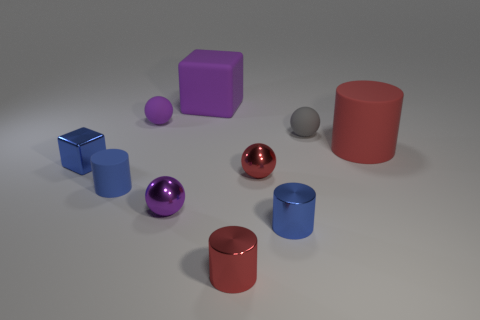What is the material of the cube that is the same color as the small rubber cylinder?
Your answer should be very brief. Metal. How many objects are the same color as the metallic cube?
Your answer should be very brief. 2. What number of objects are either blue cylinders that are to the right of the big purple rubber block or rubber objects right of the big purple thing?
Provide a succinct answer. 3. There is a cube that is in front of the large red object; what number of red rubber objects are in front of it?
Offer a terse response. 0. There is a large thing that is the same material as the large red cylinder; what is its color?
Your answer should be compact. Purple. Are there any blue rubber spheres of the same size as the purple rubber block?
Provide a succinct answer. No. There is a purple metal object that is the same size as the purple matte ball; what is its shape?
Ensure brevity in your answer.  Sphere. Is there another thing that has the same shape as the big red rubber thing?
Offer a terse response. Yes. Are the tiny blue block and the purple sphere that is in front of the tiny shiny block made of the same material?
Give a very brief answer. Yes. Is there another shiny cube of the same color as the tiny cube?
Give a very brief answer. No. 